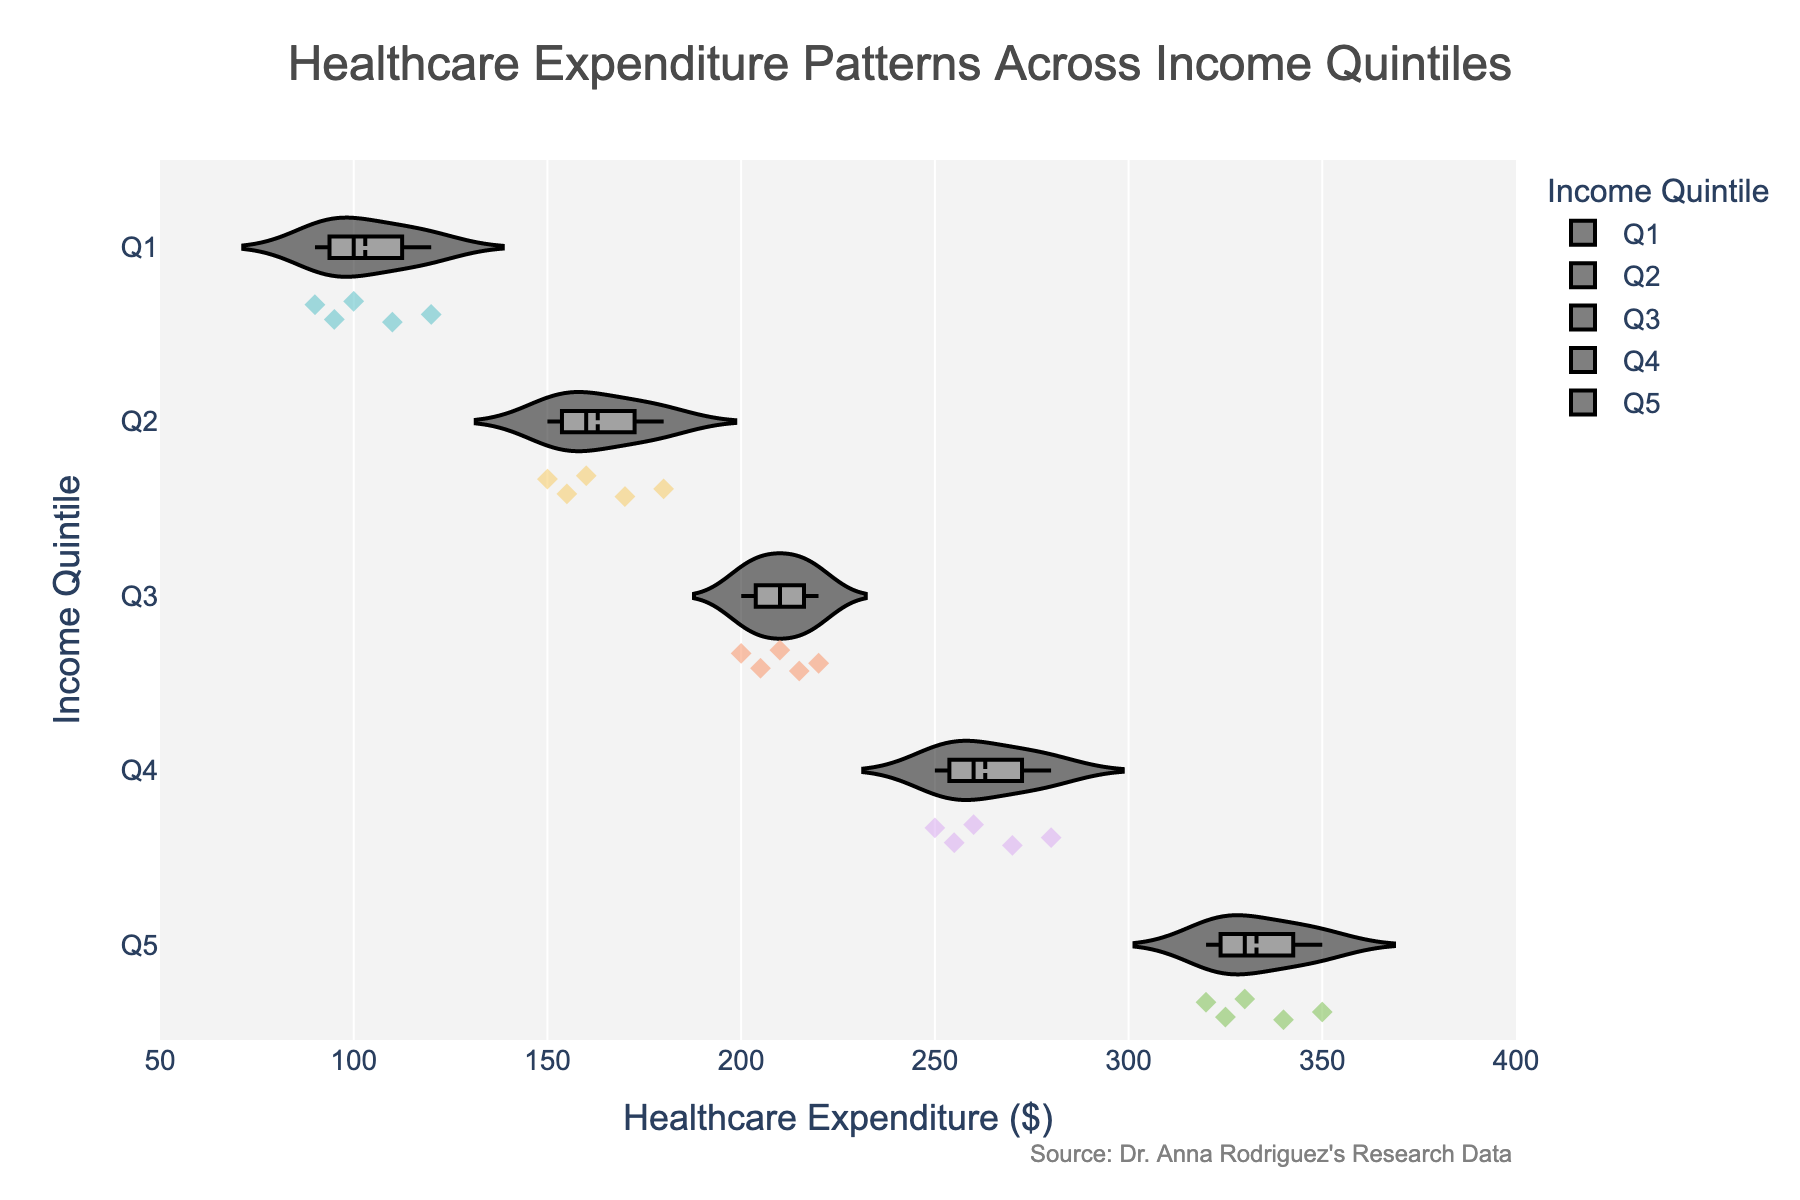What is the title of the chart? The title is found at the top of the figure. It gives an overview of what the chart is about.
Answer: Healthcare Expenditure Patterns Across Income Quintiles Which income quintile has the widest spread of healthcare expenditures? To determine the widest spread, look at the width of the violin plots. The quintile with the most extensive range of points and most spread in the distribution is Q5.
Answer: Q5 What is the median healthcare expenditure in the third income quintile (Q3)? The median can be identified from the box plot inside the violin plot. The median is the line inside the box plot for Q3.
Answer: Around $210 Which income quintile shows the highest median healthcare expenditure? Compare the medians marked within the box plots in each quintile’s violin plot. The highest median is in Q5.
Answer: Q5 How many data points are there for each income quintile? Count the number of dots within each violin plot since each dot represents a data point. Each quintile has 5 data points.
Answer: 5 What is the range of healthcare expenditures in the first income quintile (Q1)? The range is the difference between the maximum and minimum values in the violin plot. Q1 ranges from $90 to $120.
Answer: $30 Are there any outliers in the fourth income quintile (Q4)? Outliers, if any, are typically shown as points outside the box plot whiskers. In this figure, there are no apparent outliers for Q4.
Answer: No Which income quintile has the smallest spread of healthcare expenditures? The smallest spread can be identified by the narrowest width of the violin plot. The narrowest spread appears in Q1.
Answer: Q1 Compare the average healthcare expenditure between the second (Q2) and fourth (Q4) income quintiles. Calculate the average for both quintiles by summing their expenditures and then dividing by the number of data points. For Q2: (150 + 170 + 160 + 155 + 180)/5 = 163. For Q4: (250 + 270 + 260 + 255 + 280)/5 = 263.
Answer: Q4 > Q2 